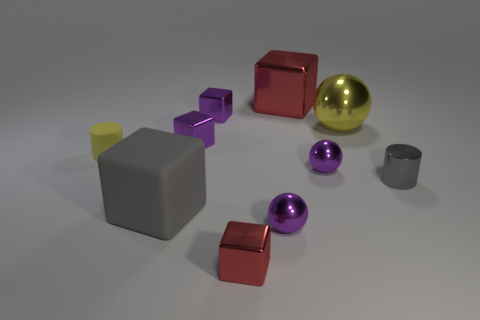Subtract all gray blocks. How many blocks are left? 4 Subtract all big gray blocks. How many blocks are left? 4 Subtract all cylinders. How many objects are left? 8 Subtract all gray cubes. Subtract all purple spheres. How many cubes are left? 4 Add 1 balls. How many balls exist? 4 Subtract 1 gray cylinders. How many objects are left? 9 Subtract all tiny purple rubber blocks. Subtract all balls. How many objects are left? 7 Add 9 gray metallic cylinders. How many gray metallic cylinders are left? 10 